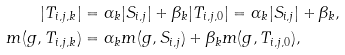Convert formula to latex. <formula><loc_0><loc_0><loc_500><loc_500>| T _ { i , j , k } | & = \alpha _ { k } | S _ { i , j } | + \beta _ { k } | T _ { i , j , 0 } | = \alpha _ { k } | S _ { i , j } | + \beta _ { k } , \\ m ( g , T _ { i , j , k } ) & = \alpha _ { k } m ( g , S _ { i , j } ) + \beta _ { k } m ( g , T _ { i , j , 0 } ) , \\</formula> 